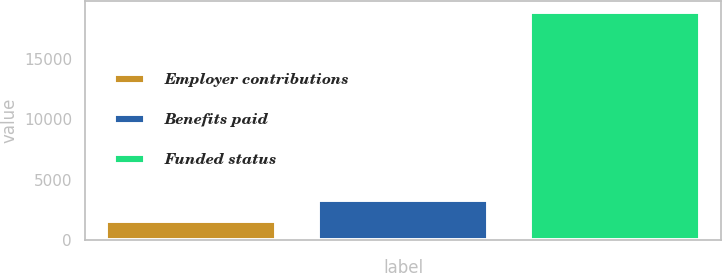Convert chart to OTSL. <chart><loc_0><loc_0><loc_500><loc_500><bar_chart><fcel>Employer contributions<fcel>Benefits paid<fcel>Funded status<nl><fcel>1610<fcel>3339.3<fcel>18903<nl></chart> 